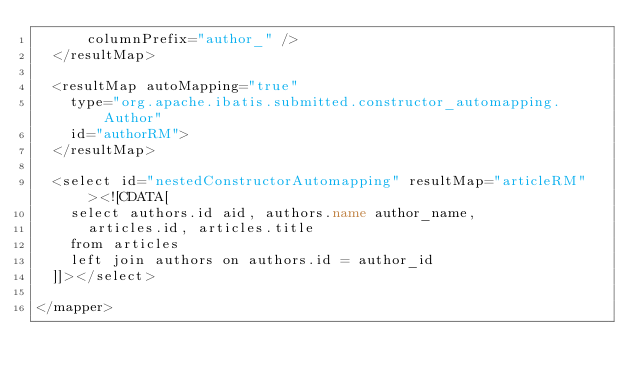Convert code to text. <code><loc_0><loc_0><loc_500><loc_500><_XML_>      columnPrefix="author_" />
  </resultMap>

  <resultMap autoMapping="true"
    type="org.apache.ibatis.submitted.constructor_automapping.Author"
    id="authorRM">
  </resultMap>

  <select id="nestedConstructorAutomapping" resultMap="articleRM"><![CDATA[
    select authors.id aid, authors.name author_name,
      articles.id, articles.title
    from articles
    left join authors on authors.id = author_id
  ]]></select>

</mapper>
</code> 